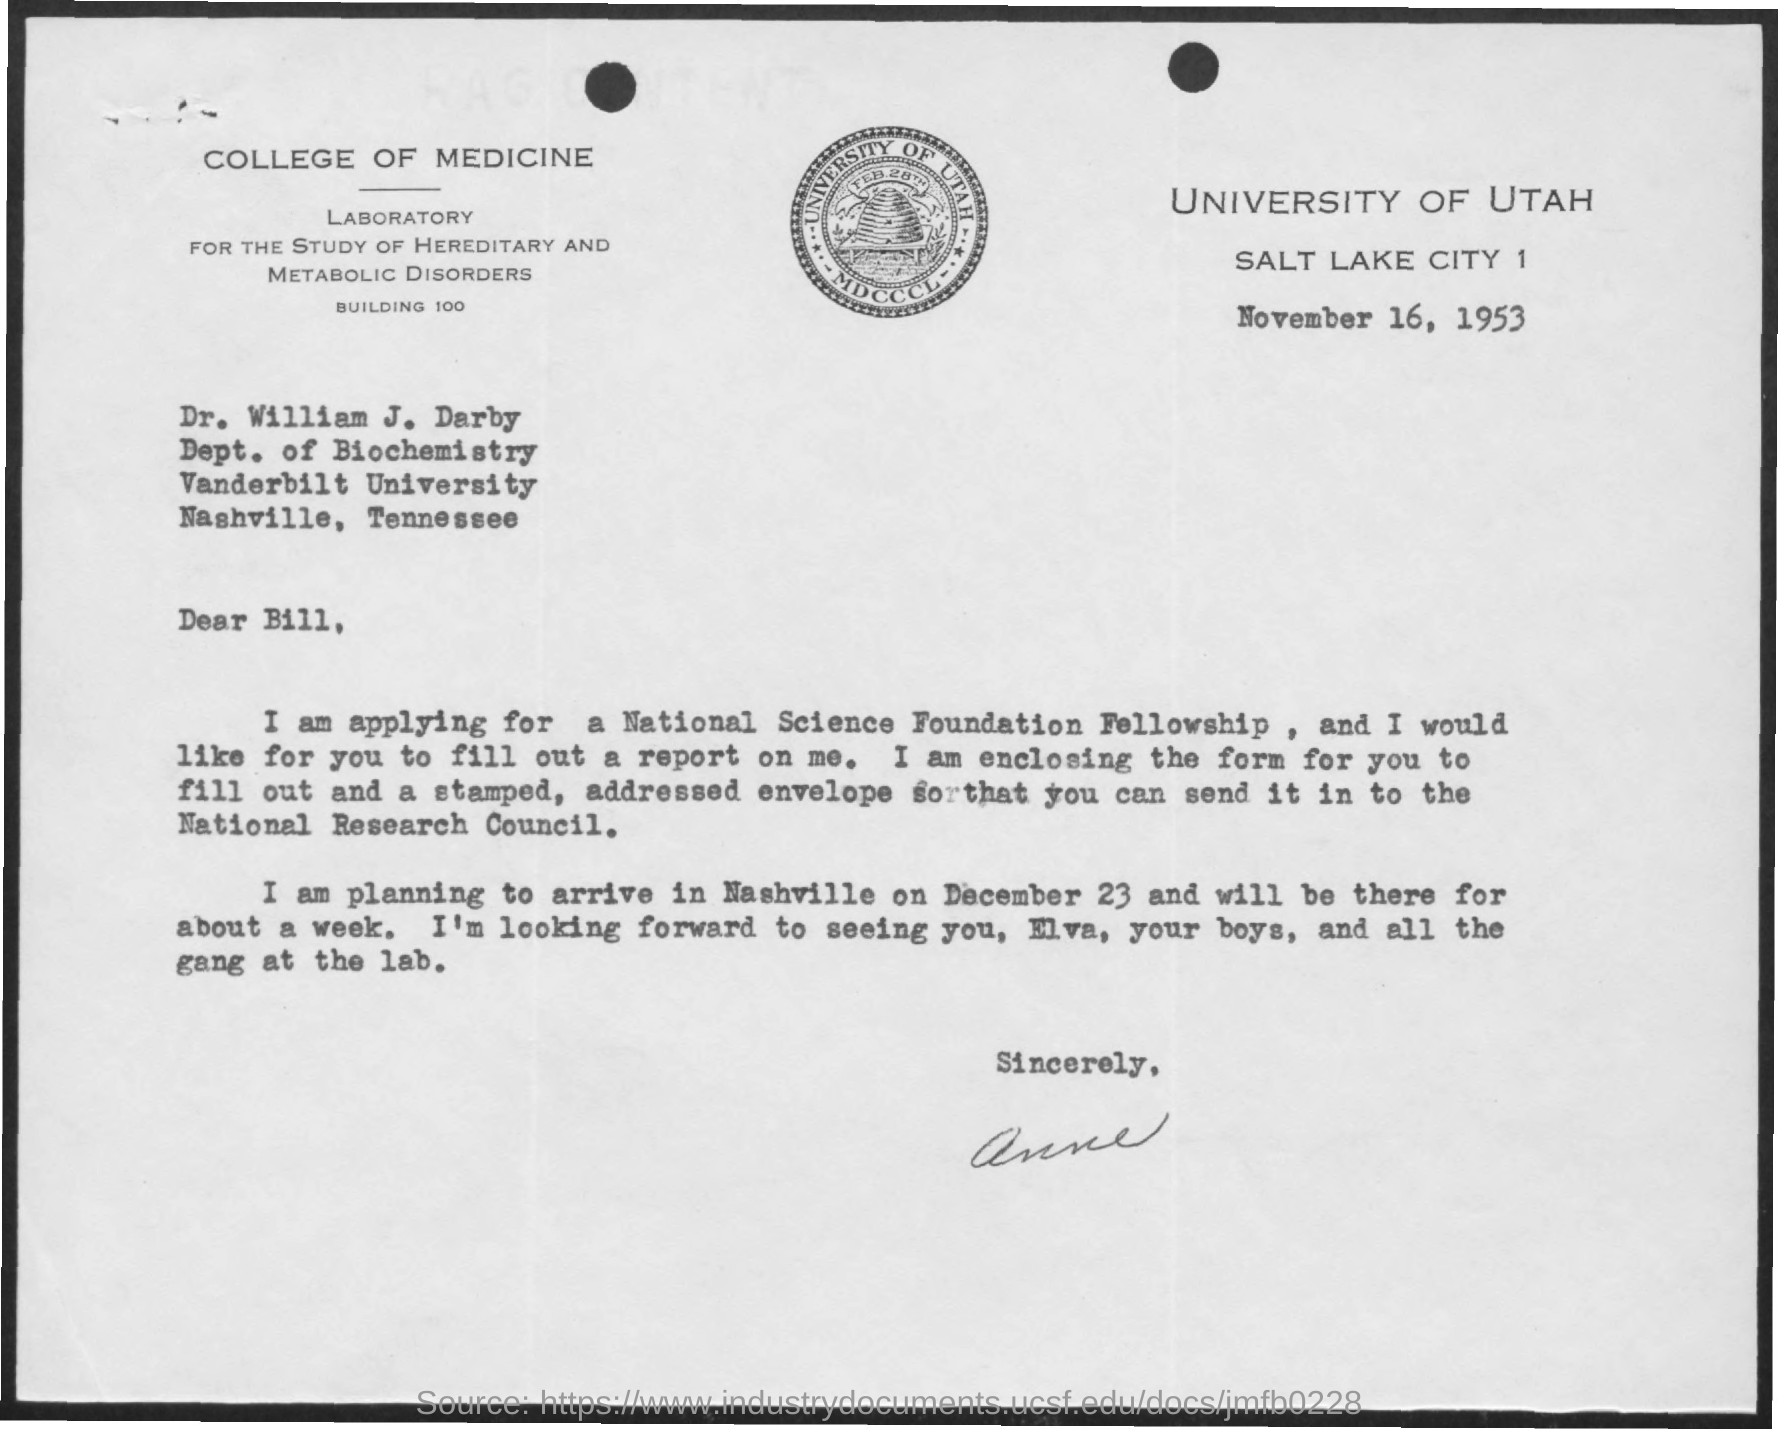Give some essential details in this illustration. The issued date of this letter is November 16, 1953. The letterhead bears the name "University of Utah. The addressee of this letter is Dr. William J. Darby. 